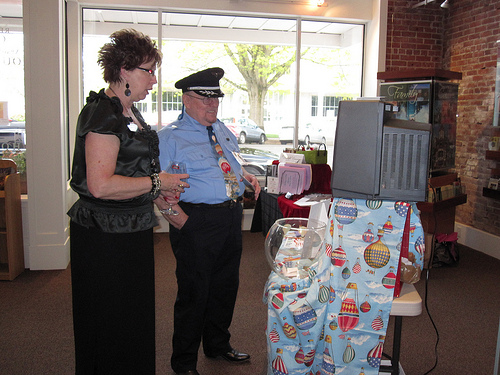<image>
Can you confirm if the man is behind the lady? No. The man is not behind the lady. From this viewpoint, the man appears to be positioned elsewhere in the scene. Is there a officer in front of the fish bowl? Yes. The officer is positioned in front of the fish bowl, appearing closer to the camera viewpoint. 